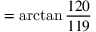Convert formula to latex. <formula><loc_0><loc_0><loc_500><loc_500>= \arctan { \frac { 1 2 0 } { 1 1 9 } }</formula> 